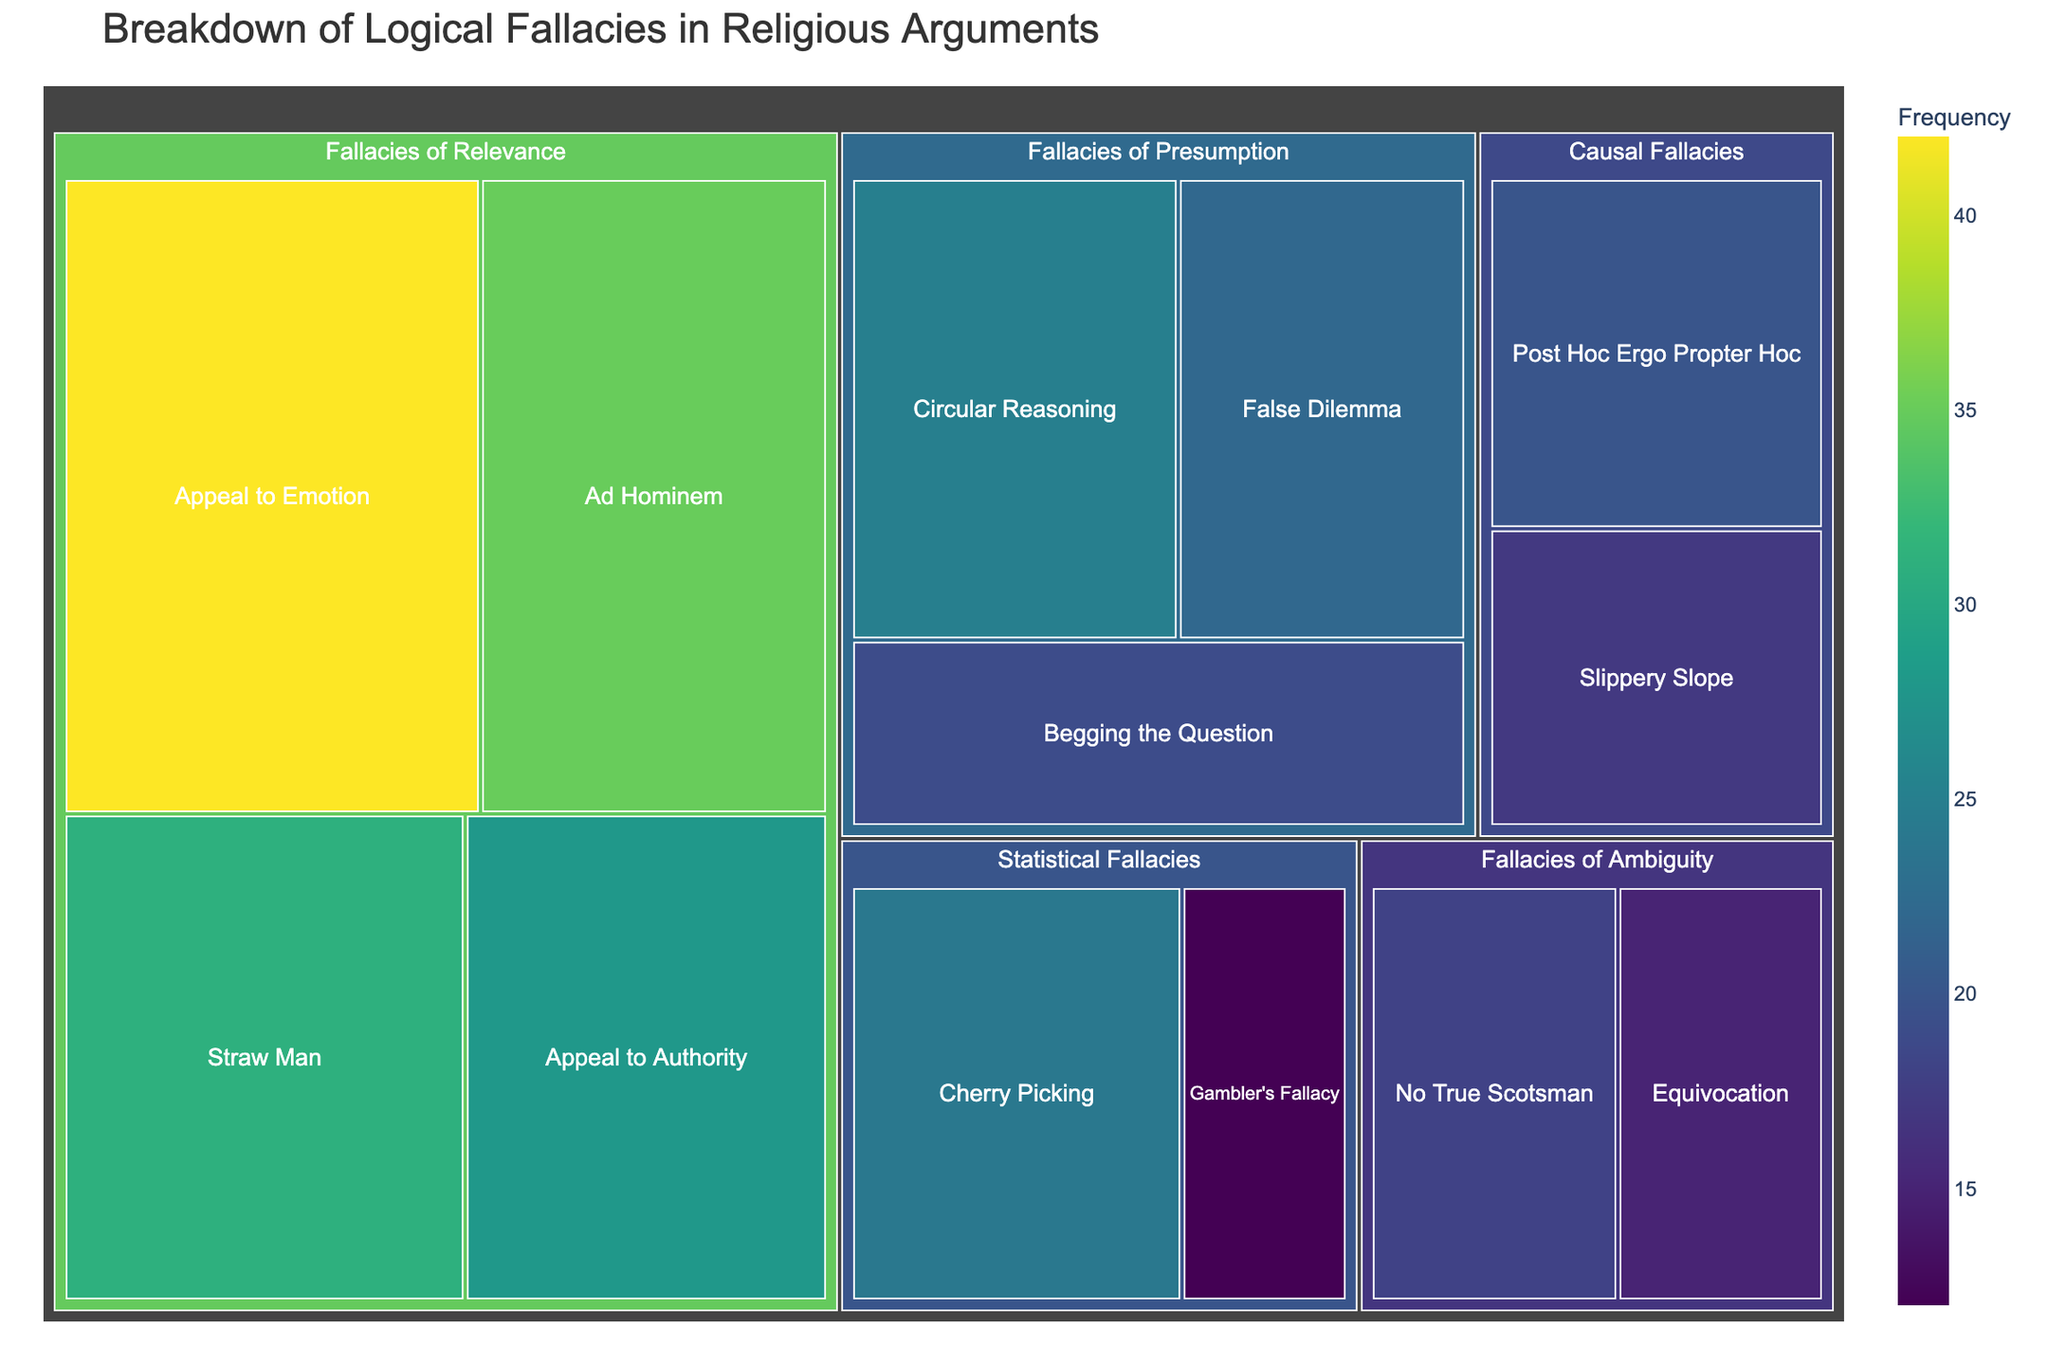what is the most frequent logical fallacy in the Treemap? To find the most frequent logical fallacy, look for the subcategory with the highest frequency value. The "Appeal to Emotion" in the "Fallacies of Relevance" category has the highest frequency of 42.
Answer: Appeal to Emotion How many logical fallacy subcategories are shown in the Treemap? To determine the number of subcategories, count each subcategory listed under the categories. There are 12 subcategories in total: Ad Hominem, Appeal to Emotion, Appeal to Authority, Straw Man, Circular Reasoning, False Dilemma, Begging the Question, Equivocation, No True Scotsman, Post Hoc Ergo Propter Hoc, Slippery Slope, Gambler's Fallacy, Cherry Picking.
Answer: 12 What is the combined frequency of all Causal Fallacies? To find the combined frequency of all Causal Fallacies, add the frequencies of "Post Hoc Ergo Propter Hoc" (20) and "Slippery Slope" (17). The sum is 20 + 17 = 37.
Answer: 37 Which subcategory in the Fallacies of Ambiguity has a higher frequency: Equivocation or No True Scotsman? To compare the frequencies, look at the values for Equivocation and No True Scotsman. Equivocation has a frequency of 15, and No True Scotsman has a frequency of 18. Thus, No True Scotsman has a higher frequency.
Answer: No True Scotsman What is the total frequency of Fallacies of Relevance? Sum the frequencies of all subcategories under Fallacies of Relevance: Ad Hominem (35), Appeal to Emotion (42), Appeal to Authority (28), Straw Man (31). The total is 35 + 42 + 28 + 31 = 136.
Answer: 136 Which logical fallacy subcategory has the lowest frequency? Identify the subcategory with the smallest frequency value. The "Gambler's Fallacy" in the "Statistical Fallacies" category has the lowest frequency of 12.
Answer: Gambler’s Fallacy Is the frequency of Circular Reasoning greater than or equal to the frequency of False Dilemma and Begging the Question combined? Compare the frequency of Circular Reasoning (25) to the sum of False Dilemma (22) and Begging the Question (19). The combined frequency is 22 + 19 = 41. Since 25 is not greater than or equal to 41, the answer is no.
Answer: No What is the difference in frequency between Ad Hominem and Straw Man? Subtract the frequency of Straw Man (31) from the frequency of Ad Hominem (35) to find the difference. The difference is 35 - 31 = 4.
Answer: 4 